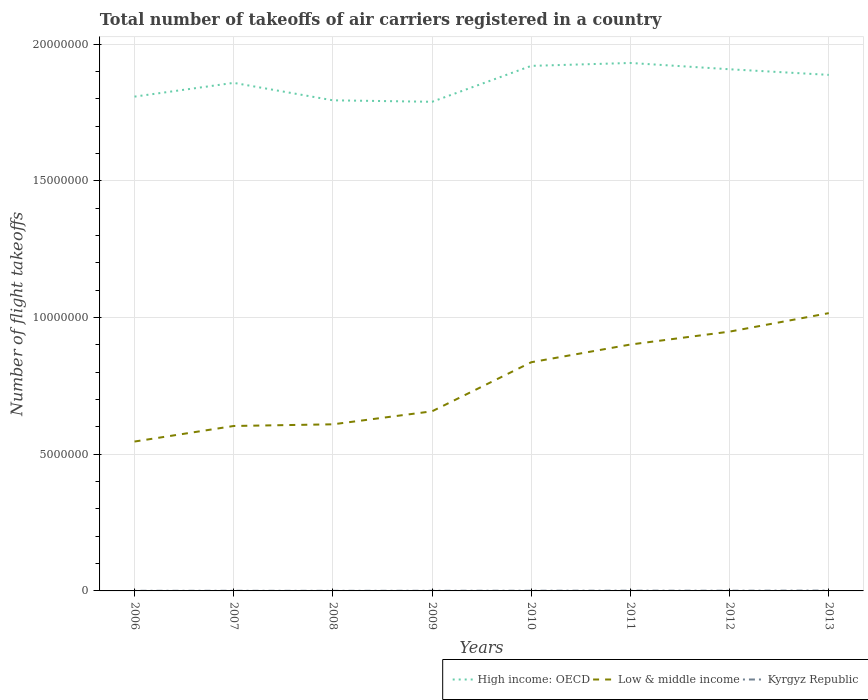Across all years, what is the maximum total number of flight takeoffs in Kyrgyz Republic?
Your response must be concise. 3567. In which year was the total number of flight takeoffs in Low & middle income maximum?
Your response must be concise. 2006. What is the total total number of flight takeoffs in Kyrgyz Republic in the graph?
Make the answer very short. -1892. What is the difference between the highest and the second highest total number of flight takeoffs in High income: OECD?
Give a very brief answer. 1.42e+06. How many lines are there?
Your response must be concise. 3. What is the difference between two consecutive major ticks on the Y-axis?
Keep it short and to the point. 5.00e+06. Are the values on the major ticks of Y-axis written in scientific E-notation?
Keep it short and to the point. No. Where does the legend appear in the graph?
Provide a short and direct response. Bottom right. How are the legend labels stacked?
Make the answer very short. Horizontal. What is the title of the graph?
Your answer should be very brief. Total number of takeoffs of air carriers registered in a country. What is the label or title of the Y-axis?
Offer a terse response. Number of flight takeoffs. What is the Number of flight takeoffs in High income: OECD in 2006?
Make the answer very short. 1.81e+07. What is the Number of flight takeoffs of Low & middle income in 2006?
Your answer should be compact. 5.46e+06. What is the Number of flight takeoffs in Kyrgyz Republic in 2006?
Make the answer very short. 4730. What is the Number of flight takeoffs in High income: OECD in 2007?
Offer a terse response. 1.86e+07. What is the Number of flight takeoffs of Low & middle income in 2007?
Your answer should be very brief. 6.03e+06. What is the Number of flight takeoffs in Kyrgyz Republic in 2007?
Your response must be concise. 4916. What is the Number of flight takeoffs in High income: OECD in 2008?
Make the answer very short. 1.79e+07. What is the Number of flight takeoffs of Low & middle income in 2008?
Provide a succinct answer. 6.09e+06. What is the Number of flight takeoffs in Kyrgyz Republic in 2008?
Your answer should be compact. 3567. What is the Number of flight takeoffs of High income: OECD in 2009?
Ensure brevity in your answer.  1.79e+07. What is the Number of flight takeoffs in Low & middle income in 2009?
Ensure brevity in your answer.  6.57e+06. What is the Number of flight takeoffs in Kyrgyz Republic in 2009?
Keep it short and to the point. 5459. What is the Number of flight takeoffs of High income: OECD in 2010?
Offer a terse response. 1.92e+07. What is the Number of flight takeoffs in Low & middle income in 2010?
Offer a terse response. 8.36e+06. What is the Number of flight takeoffs of Kyrgyz Republic in 2010?
Ensure brevity in your answer.  7371. What is the Number of flight takeoffs of High income: OECD in 2011?
Provide a succinct answer. 1.93e+07. What is the Number of flight takeoffs of Low & middle income in 2011?
Provide a succinct answer. 9.01e+06. What is the Number of flight takeoffs of Kyrgyz Republic in 2011?
Ensure brevity in your answer.  9274. What is the Number of flight takeoffs of High income: OECD in 2012?
Make the answer very short. 1.91e+07. What is the Number of flight takeoffs of Low & middle income in 2012?
Offer a terse response. 9.48e+06. What is the Number of flight takeoffs of Kyrgyz Republic in 2012?
Offer a terse response. 7719. What is the Number of flight takeoffs in High income: OECD in 2013?
Offer a very short reply. 1.89e+07. What is the Number of flight takeoffs in Low & middle income in 2013?
Your response must be concise. 1.02e+07. What is the Number of flight takeoffs in Kyrgyz Republic in 2013?
Give a very brief answer. 1.22e+04. Across all years, what is the maximum Number of flight takeoffs in High income: OECD?
Your response must be concise. 1.93e+07. Across all years, what is the maximum Number of flight takeoffs in Low & middle income?
Make the answer very short. 1.02e+07. Across all years, what is the maximum Number of flight takeoffs in Kyrgyz Republic?
Provide a short and direct response. 1.22e+04. Across all years, what is the minimum Number of flight takeoffs of High income: OECD?
Your answer should be very brief. 1.79e+07. Across all years, what is the minimum Number of flight takeoffs of Low & middle income?
Your response must be concise. 5.46e+06. Across all years, what is the minimum Number of flight takeoffs in Kyrgyz Republic?
Provide a succinct answer. 3567. What is the total Number of flight takeoffs of High income: OECD in the graph?
Keep it short and to the point. 1.49e+08. What is the total Number of flight takeoffs in Low & middle income in the graph?
Your answer should be compact. 6.12e+07. What is the total Number of flight takeoffs of Kyrgyz Republic in the graph?
Offer a terse response. 5.52e+04. What is the difference between the Number of flight takeoffs in High income: OECD in 2006 and that in 2007?
Keep it short and to the point. -5.03e+05. What is the difference between the Number of flight takeoffs in Low & middle income in 2006 and that in 2007?
Make the answer very short. -5.69e+05. What is the difference between the Number of flight takeoffs of Kyrgyz Republic in 2006 and that in 2007?
Your answer should be very brief. -186. What is the difference between the Number of flight takeoffs in High income: OECD in 2006 and that in 2008?
Your response must be concise. 1.35e+05. What is the difference between the Number of flight takeoffs in Low & middle income in 2006 and that in 2008?
Your answer should be compact. -6.30e+05. What is the difference between the Number of flight takeoffs of Kyrgyz Republic in 2006 and that in 2008?
Your answer should be compact. 1163. What is the difference between the Number of flight takeoffs in High income: OECD in 2006 and that in 2009?
Your answer should be very brief. 1.89e+05. What is the difference between the Number of flight takeoffs in Low & middle income in 2006 and that in 2009?
Offer a terse response. -1.11e+06. What is the difference between the Number of flight takeoffs of Kyrgyz Republic in 2006 and that in 2009?
Your answer should be very brief. -729. What is the difference between the Number of flight takeoffs of High income: OECD in 2006 and that in 2010?
Give a very brief answer. -1.12e+06. What is the difference between the Number of flight takeoffs in Low & middle income in 2006 and that in 2010?
Give a very brief answer. -2.90e+06. What is the difference between the Number of flight takeoffs in Kyrgyz Republic in 2006 and that in 2010?
Your response must be concise. -2641. What is the difference between the Number of flight takeoffs of High income: OECD in 2006 and that in 2011?
Your response must be concise. -1.23e+06. What is the difference between the Number of flight takeoffs of Low & middle income in 2006 and that in 2011?
Give a very brief answer. -3.55e+06. What is the difference between the Number of flight takeoffs of Kyrgyz Republic in 2006 and that in 2011?
Give a very brief answer. -4544. What is the difference between the Number of flight takeoffs in High income: OECD in 2006 and that in 2012?
Make the answer very short. -1.00e+06. What is the difference between the Number of flight takeoffs of Low & middle income in 2006 and that in 2012?
Your response must be concise. -4.02e+06. What is the difference between the Number of flight takeoffs in Kyrgyz Republic in 2006 and that in 2012?
Ensure brevity in your answer.  -2989. What is the difference between the Number of flight takeoffs in High income: OECD in 2006 and that in 2013?
Your answer should be compact. -7.95e+05. What is the difference between the Number of flight takeoffs of Low & middle income in 2006 and that in 2013?
Give a very brief answer. -4.70e+06. What is the difference between the Number of flight takeoffs in Kyrgyz Republic in 2006 and that in 2013?
Offer a terse response. -7458.42. What is the difference between the Number of flight takeoffs in High income: OECD in 2007 and that in 2008?
Keep it short and to the point. 6.38e+05. What is the difference between the Number of flight takeoffs of Low & middle income in 2007 and that in 2008?
Provide a short and direct response. -6.11e+04. What is the difference between the Number of flight takeoffs of Kyrgyz Republic in 2007 and that in 2008?
Offer a terse response. 1349. What is the difference between the Number of flight takeoffs of High income: OECD in 2007 and that in 2009?
Offer a very short reply. 6.92e+05. What is the difference between the Number of flight takeoffs of Low & middle income in 2007 and that in 2009?
Ensure brevity in your answer.  -5.37e+05. What is the difference between the Number of flight takeoffs of Kyrgyz Republic in 2007 and that in 2009?
Make the answer very short. -543. What is the difference between the Number of flight takeoffs in High income: OECD in 2007 and that in 2010?
Your response must be concise. -6.21e+05. What is the difference between the Number of flight takeoffs of Low & middle income in 2007 and that in 2010?
Offer a very short reply. -2.33e+06. What is the difference between the Number of flight takeoffs in Kyrgyz Republic in 2007 and that in 2010?
Your answer should be very brief. -2455. What is the difference between the Number of flight takeoffs in High income: OECD in 2007 and that in 2011?
Your answer should be very brief. -7.27e+05. What is the difference between the Number of flight takeoffs of Low & middle income in 2007 and that in 2011?
Offer a terse response. -2.98e+06. What is the difference between the Number of flight takeoffs of Kyrgyz Republic in 2007 and that in 2011?
Keep it short and to the point. -4358. What is the difference between the Number of flight takeoffs of High income: OECD in 2007 and that in 2012?
Offer a terse response. -4.97e+05. What is the difference between the Number of flight takeoffs of Low & middle income in 2007 and that in 2012?
Ensure brevity in your answer.  -3.45e+06. What is the difference between the Number of flight takeoffs of Kyrgyz Republic in 2007 and that in 2012?
Provide a short and direct response. -2803. What is the difference between the Number of flight takeoffs of High income: OECD in 2007 and that in 2013?
Ensure brevity in your answer.  -2.92e+05. What is the difference between the Number of flight takeoffs of Low & middle income in 2007 and that in 2013?
Your answer should be compact. -4.13e+06. What is the difference between the Number of flight takeoffs in Kyrgyz Republic in 2007 and that in 2013?
Ensure brevity in your answer.  -7272.42. What is the difference between the Number of flight takeoffs in High income: OECD in 2008 and that in 2009?
Offer a very short reply. 5.38e+04. What is the difference between the Number of flight takeoffs in Low & middle income in 2008 and that in 2009?
Your answer should be compact. -4.76e+05. What is the difference between the Number of flight takeoffs of Kyrgyz Republic in 2008 and that in 2009?
Offer a very short reply. -1892. What is the difference between the Number of flight takeoffs of High income: OECD in 2008 and that in 2010?
Give a very brief answer. -1.26e+06. What is the difference between the Number of flight takeoffs in Low & middle income in 2008 and that in 2010?
Your response must be concise. -2.27e+06. What is the difference between the Number of flight takeoffs in Kyrgyz Republic in 2008 and that in 2010?
Offer a very short reply. -3804. What is the difference between the Number of flight takeoffs in High income: OECD in 2008 and that in 2011?
Provide a short and direct response. -1.37e+06. What is the difference between the Number of flight takeoffs in Low & middle income in 2008 and that in 2011?
Your response must be concise. -2.92e+06. What is the difference between the Number of flight takeoffs in Kyrgyz Republic in 2008 and that in 2011?
Your response must be concise. -5707. What is the difference between the Number of flight takeoffs in High income: OECD in 2008 and that in 2012?
Keep it short and to the point. -1.14e+06. What is the difference between the Number of flight takeoffs in Low & middle income in 2008 and that in 2012?
Ensure brevity in your answer.  -3.39e+06. What is the difference between the Number of flight takeoffs of Kyrgyz Republic in 2008 and that in 2012?
Ensure brevity in your answer.  -4152. What is the difference between the Number of flight takeoffs of High income: OECD in 2008 and that in 2013?
Give a very brief answer. -9.30e+05. What is the difference between the Number of flight takeoffs of Low & middle income in 2008 and that in 2013?
Provide a succinct answer. -4.07e+06. What is the difference between the Number of flight takeoffs of Kyrgyz Republic in 2008 and that in 2013?
Keep it short and to the point. -8621.42. What is the difference between the Number of flight takeoffs of High income: OECD in 2009 and that in 2010?
Provide a short and direct response. -1.31e+06. What is the difference between the Number of flight takeoffs of Low & middle income in 2009 and that in 2010?
Keep it short and to the point. -1.79e+06. What is the difference between the Number of flight takeoffs in Kyrgyz Republic in 2009 and that in 2010?
Keep it short and to the point. -1912. What is the difference between the Number of flight takeoffs of High income: OECD in 2009 and that in 2011?
Offer a very short reply. -1.42e+06. What is the difference between the Number of flight takeoffs of Low & middle income in 2009 and that in 2011?
Ensure brevity in your answer.  -2.44e+06. What is the difference between the Number of flight takeoffs in Kyrgyz Republic in 2009 and that in 2011?
Provide a succinct answer. -3815. What is the difference between the Number of flight takeoffs in High income: OECD in 2009 and that in 2012?
Ensure brevity in your answer.  -1.19e+06. What is the difference between the Number of flight takeoffs of Low & middle income in 2009 and that in 2012?
Keep it short and to the point. -2.91e+06. What is the difference between the Number of flight takeoffs in Kyrgyz Republic in 2009 and that in 2012?
Provide a short and direct response. -2260. What is the difference between the Number of flight takeoffs of High income: OECD in 2009 and that in 2013?
Give a very brief answer. -9.84e+05. What is the difference between the Number of flight takeoffs of Low & middle income in 2009 and that in 2013?
Your answer should be compact. -3.59e+06. What is the difference between the Number of flight takeoffs in Kyrgyz Republic in 2009 and that in 2013?
Your answer should be very brief. -6729.42. What is the difference between the Number of flight takeoffs in High income: OECD in 2010 and that in 2011?
Keep it short and to the point. -1.06e+05. What is the difference between the Number of flight takeoffs in Low & middle income in 2010 and that in 2011?
Ensure brevity in your answer.  -6.48e+05. What is the difference between the Number of flight takeoffs of Kyrgyz Republic in 2010 and that in 2011?
Make the answer very short. -1903. What is the difference between the Number of flight takeoffs of High income: OECD in 2010 and that in 2012?
Your answer should be compact. 1.24e+05. What is the difference between the Number of flight takeoffs in Low & middle income in 2010 and that in 2012?
Offer a terse response. -1.12e+06. What is the difference between the Number of flight takeoffs in Kyrgyz Republic in 2010 and that in 2012?
Give a very brief answer. -348. What is the difference between the Number of flight takeoffs in High income: OECD in 2010 and that in 2013?
Your response must be concise. 3.29e+05. What is the difference between the Number of flight takeoffs of Low & middle income in 2010 and that in 2013?
Your answer should be compact. -1.80e+06. What is the difference between the Number of flight takeoffs of Kyrgyz Republic in 2010 and that in 2013?
Provide a succinct answer. -4817.42. What is the difference between the Number of flight takeoffs of High income: OECD in 2011 and that in 2012?
Provide a short and direct response. 2.30e+05. What is the difference between the Number of flight takeoffs in Low & middle income in 2011 and that in 2012?
Your answer should be very brief. -4.72e+05. What is the difference between the Number of flight takeoffs of Kyrgyz Republic in 2011 and that in 2012?
Ensure brevity in your answer.  1555. What is the difference between the Number of flight takeoffs in High income: OECD in 2011 and that in 2013?
Make the answer very short. 4.35e+05. What is the difference between the Number of flight takeoffs of Low & middle income in 2011 and that in 2013?
Make the answer very short. -1.15e+06. What is the difference between the Number of flight takeoffs of Kyrgyz Republic in 2011 and that in 2013?
Ensure brevity in your answer.  -2914.42. What is the difference between the Number of flight takeoffs of High income: OECD in 2012 and that in 2013?
Offer a terse response. 2.05e+05. What is the difference between the Number of flight takeoffs of Low & middle income in 2012 and that in 2013?
Offer a very short reply. -6.76e+05. What is the difference between the Number of flight takeoffs of Kyrgyz Republic in 2012 and that in 2013?
Provide a succinct answer. -4469.42. What is the difference between the Number of flight takeoffs in High income: OECD in 2006 and the Number of flight takeoffs in Low & middle income in 2007?
Your answer should be very brief. 1.20e+07. What is the difference between the Number of flight takeoffs of High income: OECD in 2006 and the Number of flight takeoffs of Kyrgyz Republic in 2007?
Keep it short and to the point. 1.81e+07. What is the difference between the Number of flight takeoffs of Low & middle income in 2006 and the Number of flight takeoffs of Kyrgyz Republic in 2007?
Give a very brief answer. 5.46e+06. What is the difference between the Number of flight takeoffs of High income: OECD in 2006 and the Number of flight takeoffs of Low & middle income in 2008?
Keep it short and to the point. 1.20e+07. What is the difference between the Number of flight takeoffs in High income: OECD in 2006 and the Number of flight takeoffs in Kyrgyz Republic in 2008?
Make the answer very short. 1.81e+07. What is the difference between the Number of flight takeoffs in Low & middle income in 2006 and the Number of flight takeoffs in Kyrgyz Republic in 2008?
Offer a very short reply. 5.46e+06. What is the difference between the Number of flight takeoffs of High income: OECD in 2006 and the Number of flight takeoffs of Low & middle income in 2009?
Make the answer very short. 1.15e+07. What is the difference between the Number of flight takeoffs of High income: OECD in 2006 and the Number of flight takeoffs of Kyrgyz Republic in 2009?
Provide a short and direct response. 1.81e+07. What is the difference between the Number of flight takeoffs in Low & middle income in 2006 and the Number of flight takeoffs in Kyrgyz Republic in 2009?
Make the answer very short. 5.46e+06. What is the difference between the Number of flight takeoffs of High income: OECD in 2006 and the Number of flight takeoffs of Low & middle income in 2010?
Ensure brevity in your answer.  9.71e+06. What is the difference between the Number of flight takeoffs of High income: OECD in 2006 and the Number of flight takeoffs of Kyrgyz Republic in 2010?
Ensure brevity in your answer.  1.81e+07. What is the difference between the Number of flight takeoffs in Low & middle income in 2006 and the Number of flight takeoffs in Kyrgyz Republic in 2010?
Provide a short and direct response. 5.46e+06. What is the difference between the Number of flight takeoffs of High income: OECD in 2006 and the Number of flight takeoffs of Low & middle income in 2011?
Your answer should be compact. 9.07e+06. What is the difference between the Number of flight takeoffs of High income: OECD in 2006 and the Number of flight takeoffs of Kyrgyz Republic in 2011?
Your answer should be compact. 1.81e+07. What is the difference between the Number of flight takeoffs in Low & middle income in 2006 and the Number of flight takeoffs in Kyrgyz Republic in 2011?
Your answer should be very brief. 5.45e+06. What is the difference between the Number of flight takeoffs in High income: OECD in 2006 and the Number of flight takeoffs in Low & middle income in 2012?
Make the answer very short. 8.59e+06. What is the difference between the Number of flight takeoffs in High income: OECD in 2006 and the Number of flight takeoffs in Kyrgyz Republic in 2012?
Make the answer very short. 1.81e+07. What is the difference between the Number of flight takeoffs in Low & middle income in 2006 and the Number of flight takeoffs in Kyrgyz Republic in 2012?
Make the answer very short. 5.46e+06. What is the difference between the Number of flight takeoffs of High income: OECD in 2006 and the Number of flight takeoffs of Low & middle income in 2013?
Provide a succinct answer. 7.92e+06. What is the difference between the Number of flight takeoffs in High income: OECD in 2006 and the Number of flight takeoffs in Kyrgyz Republic in 2013?
Give a very brief answer. 1.81e+07. What is the difference between the Number of flight takeoffs in Low & middle income in 2006 and the Number of flight takeoffs in Kyrgyz Republic in 2013?
Ensure brevity in your answer.  5.45e+06. What is the difference between the Number of flight takeoffs in High income: OECD in 2007 and the Number of flight takeoffs in Low & middle income in 2008?
Your answer should be compact. 1.25e+07. What is the difference between the Number of flight takeoffs of High income: OECD in 2007 and the Number of flight takeoffs of Kyrgyz Republic in 2008?
Offer a terse response. 1.86e+07. What is the difference between the Number of flight takeoffs of Low & middle income in 2007 and the Number of flight takeoffs of Kyrgyz Republic in 2008?
Your answer should be compact. 6.03e+06. What is the difference between the Number of flight takeoffs in High income: OECD in 2007 and the Number of flight takeoffs in Low & middle income in 2009?
Make the answer very short. 1.20e+07. What is the difference between the Number of flight takeoffs of High income: OECD in 2007 and the Number of flight takeoffs of Kyrgyz Republic in 2009?
Offer a terse response. 1.86e+07. What is the difference between the Number of flight takeoffs of Low & middle income in 2007 and the Number of flight takeoffs of Kyrgyz Republic in 2009?
Your answer should be compact. 6.03e+06. What is the difference between the Number of flight takeoffs in High income: OECD in 2007 and the Number of flight takeoffs in Low & middle income in 2010?
Give a very brief answer. 1.02e+07. What is the difference between the Number of flight takeoffs in High income: OECD in 2007 and the Number of flight takeoffs in Kyrgyz Republic in 2010?
Give a very brief answer. 1.86e+07. What is the difference between the Number of flight takeoffs of Low & middle income in 2007 and the Number of flight takeoffs of Kyrgyz Republic in 2010?
Ensure brevity in your answer.  6.02e+06. What is the difference between the Number of flight takeoffs in High income: OECD in 2007 and the Number of flight takeoffs in Low & middle income in 2011?
Give a very brief answer. 9.57e+06. What is the difference between the Number of flight takeoffs of High income: OECD in 2007 and the Number of flight takeoffs of Kyrgyz Republic in 2011?
Provide a succinct answer. 1.86e+07. What is the difference between the Number of flight takeoffs in Low & middle income in 2007 and the Number of flight takeoffs in Kyrgyz Republic in 2011?
Your response must be concise. 6.02e+06. What is the difference between the Number of flight takeoffs of High income: OECD in 2007 and the Number of flight takeoffs of Low & middle income in 2012?
Keep it short and to the point. 9.10e+06. What is the difference between the Number of flight takeoffs of High income: OECD in 2007 and the Number of flight takeoffs of Kyrgyz Republic in 2012?
Ensure brevity in your answer.  1.86e+07. What is the difference between the Number of flight takeoffs of Low & middle income in 2007 and the Number of flight takeoffs of Kyrgyz Republic in 2012?
Offer a very short reply. 6.02e+06. What is the difference between the Number of flight takeoffs in High income: OECD in 2007 and the Number of flight takeoffs in Low & middle income in 2013?
Provide a short and direct response. 8.42e+06. What is the difference between the Number of flight takeoffs of High income: OECD in 2007 and the Number of flight takeoffs of Kyrgyz Republic in 2013?
Your answer should be compact. 1.86e+07. What is the difference between the Number of flight takeoffs in Low & middle income in 2007 and the Number of flight takeoffs in Kyrgyz Republic in 2013?
Your answer should be compact. 6.02e+06. What is the difference between the Number of flight takeoffs in High income: OECD in 2008 and the Number of flight takeoffs in Low & middle income in 2009?
Keep it short and to the point. 1.14e+07. What is the difference between the Number of flight takeoffs of High income: OECD in 2008 and the Number of flight takeoffs of Kyrgyz Republic in 2009?
Provide a succinct answer. 1.79e+07. What is the difference between the Number of flight takeoffs in Low & middle income in 2008 and the Number of flight takeoffs in Kyrgyz Republic in 2009?
Your answer should be compact. 6.09e+06. What is the difference between the Number of flight takeoffs of High income: OECD in 2008 and the Number of flight takeoffs of Low & middle income in 2010?
Give a very brief answer. 9.58e+06. What is the difference between the Number of flight takeoffs in High income: OECD in 2008 and the Number of flight takeoffs in Kyrgyz Republic in 2010?
Your answer should be very brief. 1.79e+07. What is the difference between the Number of flight takeoffs in Low & middle income in 2008 and the Number of flight takeoffs in Kyrgyz Republic in 2010?
Provide a short and direct response. 6.09e+06. What is the difference between the Number of flight takeoffs in High income: OECD in 2008 and the Number of flight takeoffs in Low & middle income in 2011?
Offer a terse response. 8.93e+06. What is the difference between the Number of flight takeoffs in High income: OECD in 2008 and the Number of flight takeoffs in Kyrgyz Republic in 2011?
Provide a succinct answer. 1.79e+07. What is the difference between the Number of flight takeoffs of Low & middle income in 2008 and the Number of flight takeoffs of Kyrgyz Republic in 2011?
Give a very brief answer. 6.08e+06. What is the difference between the Number of flight takeoffs of High income: OECD in 2008 and the Number of flight takeoffs of Low & middle income in 2012?
Keep it short and to the point. 8.46e+06. What is the difference between the Number of flight takeoffs in High income: OECD in 2008 and the Number of flight takeoffs in Kyrgyz Republic in 2012?
Your answer should be compact. 1.79e+07. What is the difference between the Number of flight takeoffs in Low & middle income in 2008 and the Number of flight takeoffs in Kyrgyz Republic in 2012?
Offer a terse response. 6.09e+06. What is the difference between the Number of flight takeoffs of High income: OECD in 2008 and the Number of flight takeoffs of Low & middle income in 2013?
Offer a very short reply. 7.78e+06. What is the difference between the Number of flight takeoffs of High income: OECD in 2008 and the Number of flight takeoffs of Kyrgyz Republic in 2013?
Keep it short and to the point. 1.79e+07. What is the difference between the Number of flight takeoffs in Low & middle income in 2008 and the Number of flight takeoffs in Kyrgyz Republic in 2013?
Ensure brevity in your answer.  6.08e+06. What is the difference between the Number of flight takeoffs in High income: OECD in 2009 and the Number of flight takeoffs in Low & middle income in 2010?
Keep it short and to the point. 9.52e+06. What is the difference between the Number of flight takeoffs in High income: OECD in 2009 and the Number of flight takeoffs in Kyrgyz Republic in 2010?
Provide a short and direct response. 1.79e+07. What is the difference between the Number of flight takeoffs in Low & middle income in 2009 and the Number of flight takeoffs in Kyrgyz Republic in 2010?
Give a very brief answer. 6.56e+06. What is the difference between the Number of flight takeoffs of High income: OECD in 2009 and the Number of flight takeoffs of Low & middle income in 2011?
Provide a succinct answer. 8.88e+06. What is the difference between the Number of flight takeoffs of High income: OECD in 2009 and the Number of flight takeoffs of Kyrgyz Republic in 2011?
Your response must be concise. 1.79e+07. What is the difference between the Number of flight takeoffs in Low & middle income in 2009 and the Number of flight takeoffs in Kyrgyz Republic in 2011?
Keep it short and to the point. 6.56e+06. What is the difference between the Number of flight takeoffs in High income: OECD in 2009 and the Number of flight takeoffs in Low & middle income in 2012?
Ensure brevity in your answer.  8.40e+06. What is the difference between the Number of flight takeoffs in High income: OECD in 2009 and the Number of flight takeoffs in Kyrgyz Republic in 2012?
Provide a succinct answer. 1.79e+07. What is the difference between the Number of flight takeoffs in Low & middle income in 2009 and the Number of flight takeoffs in Kyrgyz Republic in 2012?
Your answer should be compact. 6.56e+06. What is the difference between the Number of flight takeoffs of High income: OECD in 2009 and the Number of flight takeoffs of Low & middle income in 2013?
Your response must be concise. 7.73e+06. What is the difference between the Number of flight takeoffs of High income: OECD in 2009 and the Number of flight takeoffs of Kyrgyz Republic in 2013?
Give a very brief answer. 1.79e+07. What is the difference between the Number of flight takeoffs of Low & middle income in 2009 and the Number of flight takeoffs of Kyrgyz Republic in 2013?
Provide a succinct answer. 6.56e+06. What is the difference between the Number of flight takeoffs in High income: OECD in 2010 and the Number of flight takeoffs in Low & middle income in 2011?
Provide a succinct answer. 1.02e+07. What is the difference between the Number of flight takeoffs in High income: OECD in 2010 and the Number of flight takeoffs in Kyrgyz Republic in 2011?
Offer a terse response. 1.92e+07. What is the difference between the Number of flight takeoffs of Low & middle income in 2010 and the Number of flight takeoffs of Kyrgyz Republic in 2011?
Provide a short and direct response. 8.35e+06. What is the difference between the Number of flight takeoffs of High income: OECD in 2010 and the Number of flight takeoffs of Low & middle income in 2012?
Offer a terse response. 9.72e+06. What is the difference between the Number of flight takeoffs of High income: OECD in 2010 and the Number of flight takeoffs of Kyrgyz Republic in 2012?
Ensure brevity in your answer.  1.92e+07. What is the difference between the Number of flight takeoffs of Low & middle income in 2010 and the Number of flight takeoffs of Kyrgyz Republic in 2012?
Keep it short and to the point. 8.36e+06. What is the difference between the Number of flight takeoffs of High income: OECD in 2010 and the Number of flight takeoffs of Low & middle income in 2013?
Your answer should be compact. 9.04e+06. What is the difference between the Number of flight takeoffs of High income: OECD in 2010 and the Number of flight takeoffs of Kyrgyz Republic in 2013?
Your response must be concise. 1.92e+07. What is the difference between the Number of flight takeoffs of Low & middle income in 2010 and the Number of flight takeoffs of Kyrgyz Republic in 2013?
Give a very brief answer. 8.35e+06. What is the difference between the Number of flight takeoffs of High income: OECD in 2011 and the Number of flight takeoffs of Low & middle income in 2012?
Your answer should be compact. 9.82e+06. What is the difference between the Number of flight takeoffs of High income: OECD in 2011 and the Number of flight takeoffs of Kyrgyz Republic in 2012?
Provide a short and direct response. 1.93e+07. What is the difference between the Number of flight takeoffs of Low & middle income in 2011 and the Number of flight takeoffs of Kyrgyz Republic in 2012?
Keep it short and to the point. 9.00e+06. What is the difference between the Number of flight takeoffs in High income: OECD in 2011 and the Number of flight takeoffs in Low & middle income in 2013?
Provide a short and direct response. 9.15e+06. What is the difference between the Number of flight takeoffs in High income: OECD in 2011 and the Number of flight takeoffs in Kyrgyz Republic in 2013?
Offer a very short reply. 1.93e+07. What is the difference between the Number of flight takeoffs of Low & middle income in 2011 and the Number of flight takeoffs of Kyrgyz Republic in 2013?
Provide a short and direct response. 9.00e+06. What is the difference between the Number of flight takeoffs of High income: OECD in 2012 and the Number of flight takeoffs of Low & middle income in 2013?
Your response must be concise. 8.92e+06. What is the difference between the Number of flight takeoffs of High income: OECD in 2012 and the Number of flight takeoffs of Kyrgyz Republic in 2013?
Your answer should be very brief. 1.91e+07. What is the difference between the Number of flight takeoffs of Low & middle income in 2012 and the Number of flight takeoffs of Kyrgyz Republic in 2013?
Make the answer very short. 9.47e+06. What is the average Number of flight takeoffs of High income: OECD per year?
Offer a terse response. 1.86e+07. What is the average Number of flight takeoffs of Low & middle income per year?
Offer a terse response. 7.65e+06. What is the average Number of flight takeoffs in Kyrgyz Republic per year?
Make the answer very short. 6903.05. In the year 2006, what is the difference between the Number of flight takeoffs of High income: OECD and Number of flight takeoffs of Low & middle income?
Make the answer very short. 1.26e+07. In the year 2006, what is the difference between the Number of flight takeoffs in High income: OECD and Number of flight takeoffs in Kyrgyz Republic?
Offer a terse response. 1.81e+07. In the year 2006, what is the difference between the Number of flight takeoffs in Low & middle income and Number of flight takeoffs in Kyrgyz Republic?
Ensure brevity in your answer.  5.46e+06. In the year 2007, what is the difference between the Number of flight takeoffs in High income: OECD and Number of flight takeoffs in Low & middle income?
Your answer should be very brief. 1.25e+07. In the year 2007, what is the difference between the Number of flight takeoffs of High income: OECD and Number of flight takeoffs of Kyrgyz Republic?
Keep it short and to the point. 1.86e+07. In the year 2007, what is the difference between the Number of flight takeoffs of Low & middle income and Number of flight takeoffs of Kyrgyz Republic?
Your response must be concise. 6.03e+06. In the year 2008, what is the difference between the Number of flight takeoffs in High income: OECD and Number of flight takeoffs in Low & middle income?
Offer a terse response. 1.18e+07. In the year 2008, what is the difference between the Number of flight takeoffs of High income: OECD and Number of flight takeoffs of Kyrgyz Republic?
Provide a short and direct response. 1.79e+07. In the year 2008, what is the difference between the Number of flight takeoffs of Low & middle income and Number of flight takeoffs of Kyrgyz Republic?
Your answer should be very brief. 6.09e+06. In the year 2009, what is the difference between the Number of flight takeoffs of High income: OECD and Number of flight takeoffs of Low & middle income?
Offer a terse response. 1.13e+07. In the year 2009, what is the difference between the Number of flight takeoffs in High income: OECD and Number of flight takeoffs in Kyrgyz Republic?
Your answer should be very brief. 1.79e+07. In the year 2009, what is the difference between the Number of flight takeoffs of Low & middle income and Number of flight takeoffs of Kyrgyz Republic?
Give a very brief answer. 6.56e+06. In the year 2010, what is the difference between the Number of flight takeoffs of High income: OECD and Number of flight takeoffs of Low & middle income?
Provide a succinct answer. 1.08e+07. In the year 2010, what is the difference between the Number of flight takeoffs in High income: OECD and Number of flight takeoffs in Kyrgyz Republic?
Offer a very short reply. 1.92e+07. In the year 2010, what is the difference between the Number of flight takeoffs of Low & middle income and Number of flight takeoffs of Kyrgyz Republic?
Provide a short and direct response. 8.36e+06. In the year 2011, what is the difference between the Number of flight takeoffs of High income: OECD and Number of flight takeoffs of Low & middle income?
Keep it short and to the point. 1.03e+07. In the year 2011, what is the difference between the Number of flight takeoffs in High income: OECD and Number of flight takeoffs in Kyrgyz Republic?
Give a very brief answer. 1.93e+07. In the year 2011, what is the difference between the Number of flight takeoffs of Low & middle income and Number of flight takeoffs of Kyrgyz Republic?
Your response must be concise. 9.00e+06. In the year 2012, what is the difference between the Number of flight takeoffs of High income: OECD and Number of flight takeoffs of Low & middle income?
Your response must be concise. 9.59e+06. In the year 2012, what is the difference between the Number of flight takeoffs in High income: OECD and Number of flight takeoffs in Kyrgyz Republic?
Your answer should be very brief. 1.91e+07. In the year 2012, what is the difference between the Number of flight takeoffs of Low & middle income and Number of flight takeoffs of Kyrgyz Republic?
Make the answer very short. 9.47e+06. In the year 2013, what is the difference between the Number of flight takeoffs of High income: OECD and Number of flight takeoffs of Low & middle income?
Your answer should be very brief. 8.71e+06. In the year 2013, what is the difference between the Number of flight takeoffs in High income: OECD and Number of flight takeoffs in Kyrgyz Republic?
Your answer should be compact. 1.89e+07. In the year 2013, what is the difference between the Number of flight takeoffs of Low & middle income and Number of flight takeoffs of Kyrgyz Republic?
Give a very brief answer. 1.01e+07. What is the ratio of the Number of flight takeoffs in High income: OECD in 2006 to that in 2007?
Offer a very short reply. 0.97. What is the ratio of the Number of flight takeoffs of Low & middle income in 2006 to that in 2007?
Provide a succinct answer. 0.91. What is the ratio of the Number of flight takeoffs in Kyrgyz Republic in 2006 to that in 2007?
Provide a short and direct response. 0.96. What is the ratio of the Number of flight takeoffs of High income: OECD in 2006 to that in 2008?
Make the answer very short. 1.01. What is the ratio of the Number of flight takeoffs in Low & middle income in 2006 to that in 2008?
Offer a terse response. 0.9. What is the ratio of the Number of flight takeoffs in Kyrgyz Republic in 2006 to that in 2008?
Provide a succinct answer. 1.33. What is the ratio of the Number of flight takeoffs of High income: OECD in 2006 to that in 2009?
Offer a terse response. 1.01. What is the ratio of the Number of flight takeoffs in Low & middle income in 2006 to that in 2009?
Provide a succinct answer. 0.83. What is the ratio of the Number of flight takeoffs of Kyrgyz Republic in 2006 to that in 2009?
Ensure brevity in your answer.  0.87. What is the ratio of the Number of flight takeoffs in High income: OECD in 2006 to that in 2010?
Your answer should be very brief. 0.94. What is the ratio of the Number of flight takeoffs in Low & middle income in 2006 to that in 2010?
Provide a succinct answer. 0.65. What is the ratio of the Number of flight takeoffs of Kyrgyz Republic in 2006 to that in 2010?
Provide a succinct answer. 0.64. What is the ratio of the Number of flight takeoffs in High income: OECD in 2006 to that in 2011?
Your response must be concise. 0.94. What is the ratio of the Number of flight takeoffs of Low & middle income in 2006 to that in 2011?
Provide a succinct answer. 0.61. What is the ratio of the Number of flight takeoffs in Kyrgyz Republic in 2006 to that in 2011?
Provide a succinct answer. 0.51. What is the ratio of the Number of flight takeoffs in High income: OECD in 2006 to that in 2012?
Your response must be concise. 0.95. What is the ratio of the Number of flight takeoffs in Low & middle income in 2006 to that in 2012?
Your response must be concise. 0.58. What is the ratio of the Number of flight takeoffs in Kyrgyz Republic in 2006 to that in 2012?
Your answer should be compact. 0.61. What is the ratio of the Number of flight takeoffs in High income: OECD in 2006 to that in 2013?
Give a very brief answer. 0.96. What is the ratio of the Number of flight takeoffs of Low & middle income in 2006 to that in 2013?
Keep it short and to the point. 0.54. What is the ratio of the Number of flight takeoffs of Kyrgyz Republic in 2006 to that in 2013?
Ensure brevity in your answer.  0.39. What is the ratio of the Number of flight takeoffs in High income: OECD in 2007 to that in 2008?
Make the answer very short. 1.04. What is the ratio of the Number of flight takeoffs in Kyrgyz Republic in 2007 to that in 2008?
Provide a short and direct response. 1.38. What is the ratio of the Number of flight takeoffs in High income: OECD in 2007 to that in 2009?
Provide a succinct answer. 1.04. What is the ratio of the Number of flight takeoffs of Low & middle income in 2007 to that in 2009?
Make the answer very short. 0.92. What is the ratio of the Number of flight takeoffs of Kyrgyz Republic in 2007 to that in 2009?
Keep it short and to the point. 0.9. What is the ratio of the Number of flight takeoffs of Low & middle income in 2007 to that in 2010?
Offer a very short reply. 0.72. What is the ratio of the Number of flight takeoffs of Kyrgyz Republic in 2007 to that in 2010?
Make the answer very short. 0.67. What is the ratio of the Number of flight takeoffs in High income: OECD in 2007 to that in 2011?
Offer a terse response. 0.96. What is the ratio of the Number of flight takeoffs of Low & middle income in 2007 to that in 2011?
Offer a terse response. 0.67. What is the ratio of the Number of flight takeoffs of Kyrgyz Republic in 2007 to that in 2011?
Your answer should be compact. 0.53. What is the ratio of the Number of flight takeoffs in High income: OECD in 2007 to that in 2012?
Your answer should be compact. 0.97. What is the ratio of the Number of flight takeoffs in Low & middle income in 2007 to that in 2012?
Provide a short and direct response. 0.64. What is the ratio of the Number of flight takeoffs in Kyrgyz Republic in 2007 to that in 2012?
Offer a terse response. 0.64. What is the ratio of the Number of flight takeoffs of High income: OECD in 2007 to that in 2013?
Your answer should be very brief. 0.98. What is the ratio of the Number of flight takeoffs in Low & middle income in 2007 to that in 2013?
Your response must be concise. 0.59. What is the ratio of the Number of flight takeoffs in Kyrgyz Republic in 2007 to that in 2013?
Provide a succinct answer. 0.4. What is the ratio of the Number of flight takeoffs of Low & middle income in 2008 to that in 2009?
Your answer should be compact. 0.93. What is the ratio of the Number of flight takeoffs in Kyrgyz Republic in 2008 to that in 2009?
Provide a succinct answer. 0.65. What is the ratio of the Number of flight takeoffs of High income: OECD in 2008 to that in 2010?
Your answer should be very brief. 0.93. What is the ratio of the Number of flight takeoffs of Low & middle income in 2008 to that in 2010?
Offer a very short reply. 0.73. What is the ratio of the Number of flight takeoffs in Kyrgyz Republic in 2008 to that in 2010?
Your response must be concise. 0.48. What is the ratio of the Number of flight takeoffs in High income: OECD in 2008 to that in 2011?
Your response must be concise. 0.93. What is the ratio of the Number of flight takeoffs of Low & middle income in 2008 to that in 2011?
Make the answer very short. 0.68. What is the ratio of the Number of flight takeoffs of Kyrgyz Republic in 2008 to that in 2011?
Offer a very short reply. 0.38. What is the ratio of the Number of flight takeoffs in High income: OECD in 2008 to that in 2012?
Provide a short and direct response. 0.94. What is the ratio of the Number of flight takeoffs of Low & middle income in 2008 to that in 2012?
Provide a short and direct response. 0.64. What is the ratio of the Number of flight takeoffs of Kyrgyz Republic in 2008 to that in 2012?
Provide a succinct answer. 0.46. What is the ratio of the Number of flight takeoffs in High income: OECD in 2008 to that in 2013?
Your answer should be very brief. 0.95. What is the ratio of the Number of flight takeoffs of Low & middle income in 2008 to that in 2013?
Provide a succinct answer. 0.6. What is the ratio of the Number of flight takeoffs in Kyrgyz Republic in 2008 to that in 2013?
Make the answer very short. 0.29. What is the ratio of the Number of flight takeoffs of High income: OECD in 2009 to that in 2010?
Offer a very short reply. 0.93. What is the ratio of the Number of flight takeoffs in Low & middle income in 2009 to that in 2010?
Provide a short and direct response. 0.79. What is the ratio of the Number of flight takeoffs of Kyrgyz Republic in 2009 to that in 2010?
Offer a very short reply. 0.74. What is the ratio of the Number of flight takeoffs in High income: OECD in 2009 to that in 2011?
Give a very brief answer. 0.93. What is the ratio of the Number of flight takeoffs of Low & middle income in 2009 to that in 2011?
Your response must be concise. 0.73. What is the ratio of the Number of flight takeoffs of Kyrgyz Republic in 2009 to that in 2011?
Offer a terse response. 0.59. What is the ratio of the Number of flight takeoffs in High income: OECD in 2009 to that in 2012?
Your answer should be very brief. 0.94. What is the ratio of the Number of flight takeoffs in Low & middle income in 2009 to that in 2012?
Ensure brevity in your answer.  0.69. What is the ratio of the Number of flight takeoffs of Kyrgyz Republic in 2009 to that in 2012?
Offer a terse response. 0.71. What is the ratio of the Number of flight takeoffs of High income: OECD in 2009 to that in 2013?
Keep it short and to the point. 0.95. What is the ratio of the Number of flight takeoffs of Low & middle income in 2009 to that in 2013?
Keep it short and to the point. 0.65. What is the ratio of the Number of flight takeoffs of Kyrgyz Republic in 2009 to that in 2013?
Provide a succinct answer. 0.45. What is the ratio of the Number of flight takeoffs in Low & middle income in 2010 to that in 2011?
Offer a terse response. 0.93. What is the ratio of the Number of flight takeoffs in Kyrgyz Republic in 2010 to that in 2011?
Your response must be concise. 0.79. What is the ratio of the Number of flight takeoffs of High income: OECD in 2010 to that in 2012?
Give a very brief answer. 1.01. What is the ratio of the Number of flight takeoffs in Low & middle income in 2010 to that in 2012?
Keep it short and to the point. 0.88. What is the ratio of the Number of flight takeoffs of Kyrgyz Republic in 2010 to that in 2012?
Your response must be concise. 0.95. What is the ratio of the Number of flight takeoffs of High income: OECD in 2010 to that in 2013?
Your answer should be compact. 1.02. What is the ratio of the Number of flight takeoffs in Low & middle income in 2010 to that in 2013?
Your answer should be very brief. 0.82. What is the ratio of the Number of flight takeoffs of Kyrgyz Republic in 2010 to that in 2013?
Offer a terse response. 0.6. What is the ratio of the Number of flight takeoffs in High income: OECD in 2011 to that in 2012?
Your answer should be compact. 1.01. What is the ratio of the Number of flight takeoffs of Low & middle income in 2011 to that in 2012?
Your response must be concise. 0.95. What is the ratio of the Number of flight takeoffs in Kyrgyz Republic in 2011 to that in 2012?
Ensure brevity in your answer.  1.2. What is the ratio of the Number of flight takeoffs of High income: OECD in 2011 to that in 2013?
Your answer should be compact. 1.02. What is the ratio of the Number of flight takeoffs of Low & middle income in 2011 to that in 2013?
Keep it short and to the point. 0.89. What is the ratio of the Number of flight takeoffs in Kyrgyz Republic in 2011 to that in 2013?
Ensure brevity in your answer.  0.76. What is the ratio of the Number of flight takeoffs of High income: OECD in 2012 to that in 2013?
Provide a succinct answer. 1.01. What is the ratio of the Number of flight takeoffs in Low & middle income in 2012 to that in 2013?
Keep it short and to the point. 0.93. What is the ratio of the Number of flight takeoffs of Kyrgyz Republic in 2012 to that in 2013?
Keep it short and to the point. 0.63. What is the difference between the highest and the second highest Number of flight takeoffs in High income: OECD?
Give a very brief answer. 1.06e+05. What is the difference between the highest and the second highest Number of flight takeoffs of Low & middle income?
Keep it short and to the point. 6.76e+05. What is the difference between the highest and the second highest Number of flight takeoffs of Kyrgyz Republic?
Offer a terse response. 2914.42. What is the difference between the highest and the lowest Number of flight takeoffs in High income: OECD?
Offer a very short reply. 1.42e+06. What is the difference between the highest and the lowest Number of flight takeoffs of Low & middle income?
Provide a succinct answer. 4.70e+06. What is the difference between the highest and the lowest Number of flight takeoffs of Kyrgyz Republic?
Offer a very short reply. 8621.42. 